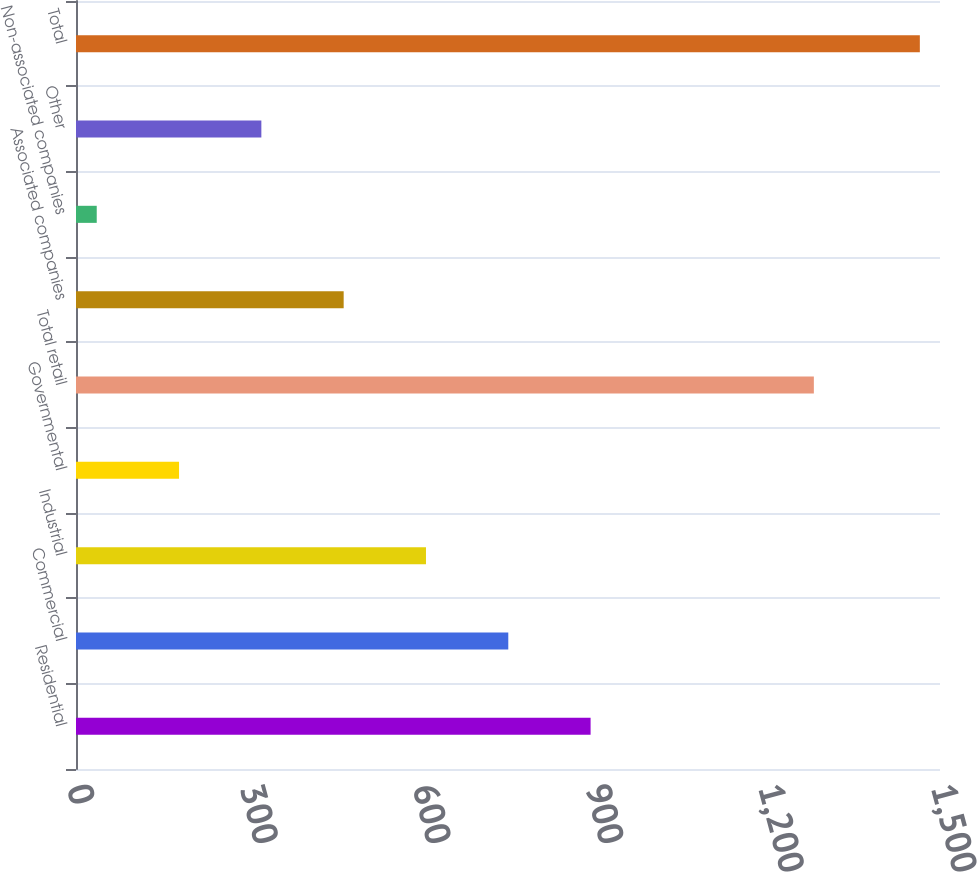Convert chart to OTSL. <chart><loc_0><loc_0><loc_500><loc_500><bar_chart><fcel>Residential<fcel>Commercial<fcel>Industrial<fcel>Governmental<fcel>Total retail<fcel>Associated companies<fcel>Non-associated companies<fcel>Other<fcel>Total<nl><fcel>893.4<fcel>750.5<fcel>607.6<fcel>178.9<fcel>1281<fcel>464.7<fcel>36<fcel>321.8<fcel>1465<nl></chart> 